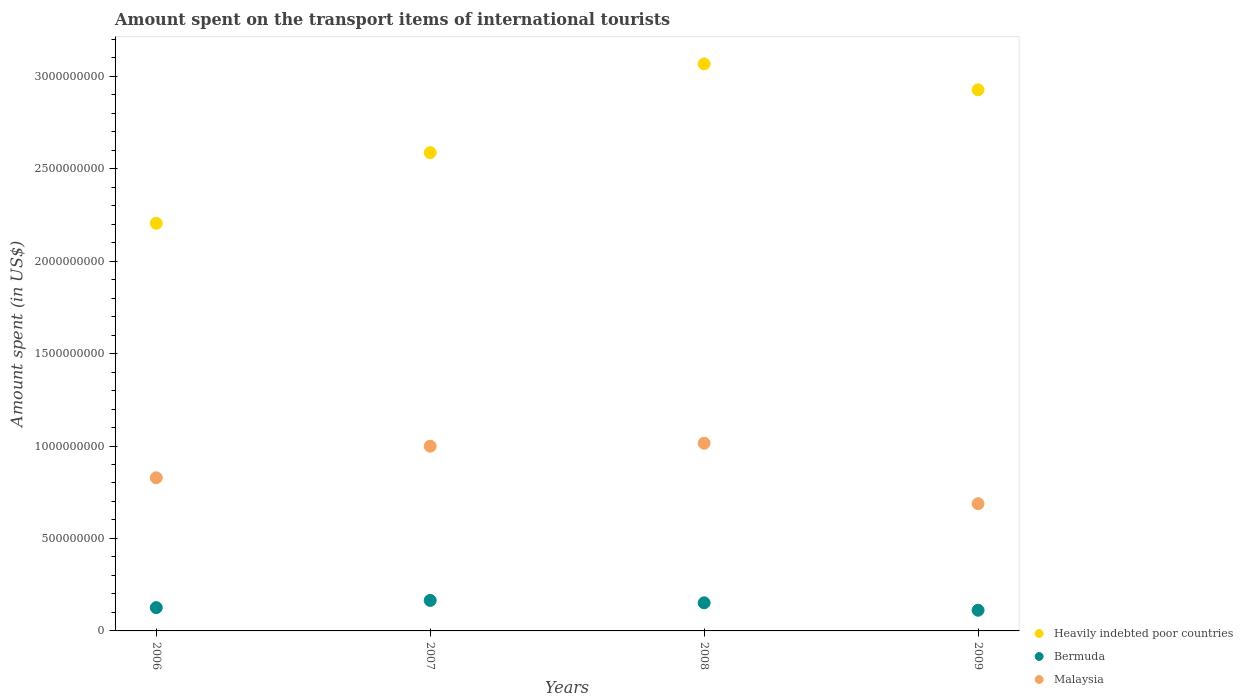What is the amount spent on the transport items of international tourists in Heavily indebted poor countries in 2006?
Offer a very short reply. 2.20e+09. Across all years, what is the maximum amount spent on the transport items of international tourists in Heavily indebted poor countries?
Your response must be concise. 3.07e+09. Across all years, what is the minimum amount spent on the transport items of international tourists in Bermuda?
Offer a terse response. 1.12e+08. In which year was the amount spent on the transport items of international tourists in Heavily indebted poor countries maximum?
Keep it short and to the point. 2008. In which year was the amount spent on the transport items of international tourists in Bermuda minimum?
Offer a terse response. 2009. What is the total amount spent on the transport items of international tourists in Bermuda in the graph?
Offer a very short reply. 5.55e+08. What is the difference between the amount spent on the transport items of international tourists in Bermuda in 2007 and that in 2008?
Your answer should be compact. 1.30e+07. What is the difference between the amount spent on the transport items of international tourists in Malaysia in 2006 and the amount spent on the transport items of international tourists in Heavily indebted poor countries in 2008?
Provide a short and direct response. -2.24e+09. What is the average amount spent on the transport items of international tourists in Malaysia per year?
Offer a terse response. 8.82e+08. In the year 2008, what is the difference between the amount spent on the transport items of international tourists in Heavily indebted poor countries and amount spent on the transport items of international tourists in Bermuda?
Make the answer very short. 2.91e+09. What is the ratio of the amount spent on the transport items of international tourists in Heavily indebted poor countries in 2006 to that in 2008?
Provide a short and direct response. 0.72. What is the difference between the highest and the second highest amount spent on the transport items of international tourists in Malaysia?
Your answer should be compact. 1.60e+07. What is the difference between the highest and the lowest amount spent on the transport items of international tourists in Bermuda?
Provide a short and direct response. 5.30e+07. Is it the case that in every year, the sum of the amount spent on the transport items of international tourists in Malaysia and amount spent on the transport items of international tourists in Heavily indebted poor countries  is greater than the amount spent on the transport items of international tourists in Bermuda?
Offer a very short reply. Yes. Does the amount spent on the transport items of international tourists in Malaysia monotonically increase over the years?
Ensure brevity in your answer.  No. Is the amount spent on the transport items of international tourists in Heavily indebted poor countries strictly greater than the amount spent on the transport items of international tourists in Bermuda over the years?
Make the answer very short. Yes. How many dotlines are there?
Make the answer very short. 3. How many years are there in the graph?
Provide a short and direct response. 4. What is the difference between two consecutive major ticks on the Y-axis?
Give a very brief answer. 5.00e+08. Are the values on the major ticks of Y-axis written in scientific E-notation?
Offer a very short reply. No. Does the graph contain any zero values?
Ensure brevity in your answer.  No. Does the graph contain grids?
Ensure brevity in your answer.  No. Where does the legend appear in the graph?
Keep it short and to the point. Bottom right. How many legend labels are there?
Ensure brevity in your answer.  3. What is the title of the graph?
Your answer should be very brief. Amount spent on the transport items of international tourists. Does "Lithuania" appear as one of the legend labels in the graph?
Provide a short and direct response. No. What is the label or title of the X-axis?
Provide a short and direct response. Years. What is the label or title of the Y-axis?
Your answer should be very brief. Amount spent (in US$). What is the Amount spent (in US$) of Heavily indebted poor countries in 2006?
Your response must be concise. 2.20e+09. What is the Amount spent (in US$) of Bermuda in 2006?
Your answer should be very brief. 1.26e+08. What is the Amount spent (in US$) in Malaysia in 2006?
Your response must be concise. 8.28e+08. What is the Amount spent (in US$) of Heavily indebted poor countries in 2007?
Provide a short and direct response. 2.59e+09. What is the Amount spent (in US$) in Bermuda in 2007?
Provide a succinct answer. 1.65e+08. What is the Amount spent (in US$) in Malaysia in 2007?
Your answer should be very brief. 9.99e+08. What is the Amount spent (in US$) in Heavily indebted poor countries in 2008?
Provide a succinct answer. 3.07e+09. What is the Amount spent (in US$) of Bermuda in 2008?
Offer a very short reply. 1.52e+08. What is the Amount spent (in US$) in Malaysia in 2008?
Offer a terse response. 1.02e+09. What is the Amount spent (in US$) in Heavily indebted poor countries in 2009?
Ensure brevity in your answer.  2.93e+09. What is the Amount spent (in US$) in Bermuda in 2009?
Provide a succinct answer. 1.12e+08. What is the Amount spent (in US$) in Malaysia in 2009?
Keep it short and to the point. 6.88e+08. Across all years, what is the maximum Amount spent (in US$) in Heavily indebted poor countries?
Your answer should be compact. 3.07e+09. Across all years, what is the maximum Amount spent (in US$) in Bermuda?
Give a very brief answer. 1.65e+08. Across all years, what is the maximum Amount spent (in US$) of Malaysia?
Your answer should be very brief. 1.02e+09. Across all years, what is the minimum Amount spent (in US$) in Heavily indebted poor countries?
Your answer should be compact. 2.20e+09. Across all years, what is the minimum Amount spent (in US$) in Bermuda?
Give a very brief answer. 1.12e+08. Across all years, what is the minimum Amount spent (in US$) in Malaysia?
Ensure brevity in your answer.  6.88e+08. What is the total Amount spent (in US$) of Heavily indebted poor countries in the graph?
Offer a terse response. 1.08e+1. What is the total Amount spent (in US$) in Bermuda in the graph?
Give a very brief answer. 5.55e+08. What is the total Amount spent (in US$) of Malaysia in the graph?
Give a very brief answer. 3.53e+09. What is the difference between the Amount spent (in US$) in Heavily indebted poor countries in 2006 and that in 2007?
Ensure brevity in your answer.  -3.82e+08. What is the difference between the Amount spent (in US$) of Bermuda in 2006 and that in 2007?
Ensure brevity in your answer.  -3.90e+07. What is the difference between the Amount spent (in US$) in Malaysia in 2006 and that in 2007?
Your answer should be compact. -1.71e+08. What is the difference between the Amount spent (in US$) in Heavily indebted poor countries in 2006 and that in 2008?
Your answer should be very brief. -8.62e+08. What is the difference between the Amount spent (in US$) of Bermuda in 2006 and that in 2008?
Your answer should be very brief. -2.60e+07. What is the difference between the Amount spent (in US$) in Malaysia in 2006 and that in 2008?
Offer a very short reply. -1.87e+08. What is the difference between the Amount spent (in US$) of Heavily indebted poor countries in 2006 and that in 2009?
Keep it short and to the point. -7.22e+08. What is the difference between the Amount spent (in US$) in Bermuda in 2006 and that in 2009?
Keep it short and to the point. 1.40e+07. What is the difference between the Amount spent (in US$) in Malaysia in 2006 and that in 2009?
Your answer should be compact. 1.40e+08. What is the difference between the Amount spent (in US$) in Heavily indebted poor countries in 2007 and that in 2008?
Your answer should be very brief. -4.80e+08. What is the difference between the Amount spent (in US$) of Bermuda in 2007 and that in 2008?
Give a very brief answer. 1.30e+07. What is the difference between the Amount spent (in US$) in Malaysia in 2007 and that in 2008?
Keep it short and to the point. -1.60e+07. What is the difference between the Amount spent (in US$) of Heavily indebted poor countries in 2007 and that in 2009?
Give a very brief answer. -3.40e+08. What is the difference between the Amount spent (in US$) of Bermuda in 2007 and that in 2009?
Offer a terse response. 5.30e+07. What is the difference between the Amount spent (in US$) of Malaysia in 2007 and that in 2009?
Your answer should be compact. 3.11e+08. What is the difference between the Amount spent (in US$) in Heavily indebted poor countries in 2008 and that in 2009?
Give a very brief answer. 1.40e+08. What is the difference between the Amount spent (in US$) in Bermuda in 2008 and that in 2009?
Offer a terse response. 4.00e+07. What is the difference between the Amount spent (in US$) in Malaysia in 2008 and that in 2009?
Keep it short and to the point. 3.27e+08. What is the difference between the Amount spent (in US$) in Heavily indebted poor countries in 2006 and the Amount spent (in US$) in Bermuda in 2007?
Offer a terse response. 2.04e+09. What is the difference between the Amount spent (in US$) of Heavily indebted poor countries in 2006 and the Amount spent (in US$) of Malaysia in 2007?
Your answer should be compact. 1.21e+09. What is the difference between the Amount spent (in US$) in Bermuda in 2006 and the Amount spent (in US$) in Malaysia in 2007?
Offer a very short reply. -8.73e+08. What is the difference between the Amount spent (in US$) in Heavily indebted poor countries in 2006 and the Amount spent (in US$) in Bermuda in 2008?
Your response must be concise. 2.05e+09. What is the difference between the Amount spent (in US$) of Heavily indebted poor countries in 2006 and the Amount spent (in US$) of Malaysia in 2008?
Provide a short and direct response. 1.19e+09. What is the difference between the Amount spent (in US$) in Bermuda in 2006 and the Amount spent (in US$) in Malaysia in 2008?
Your response must be concise. -8.89e+08. What is the difference between the Amount spent (in US$) in Heavily indebted poor countries in 2006 and the Amount spent (in US$) in Bermuda in 2009?
Provide a short and direct response. 2.09e+09. What is the difference between the Amount spent (in US$) of Heavily indebted poor countries in 2006 and the Amount spent (in US$) of Malaysia in 2009?
Offer a very short reply. 1.52e+09. What is the difference between the Amount spent (in US$) of Bermuda in 2006 and the Amount spent (in US$) of Malaysia in 2009?
Offer a very short reply. -5.62e+08. What is the difference between the Amount spent (in US$) of Heavily indebted poor countries in 2007 and the Amount spent (in US$) of Bermuda in 2008?
Give a very brief answer. 2.43e+09. What is the difference between the Amount spent (in US$) of Heavily indebted poor countries in 2007 and the Amount spent (in US$) of Malaysia in 2008?
Your answer should be very brief. 1.57e+09. What is the difference between the Amount spent (in US$) in Bermuda in 2007 and the Amount spent (in US$) in Malaysia in 2008?
Your answer should be very brief. -8.50e+08. What is the difference between the Amount spent (in US$) in Heavily indebted poor countries in 2007 and the Amount spent (in US$) in Bermuda in 2009?
Provide a succinct answer. 2.47e+09. What is the difference between the Amount spent (in US$) in Heavily indebted poor countries in 2007 and the Amount spent (in US$) in Malaysia in 2009?
Provide a succinct answer. 1.90e+09. What is the difference between the Amount spent (in US$) in Bermuda in 2007 and the Amount spent (in US$) in Malaysia in 2009?
Provide a short and direct response. -5.23e+08. What is the difference between the Amount spent (in US$) of Heavily indebted poor countries in 2008 and the Amount spent (in US$) of Bermuda in 2009?
Offer a terse response. 2.95e+09. What is the difference between the Amount spent (in US$) of Heavily indebted poor countries in 2008 and the Amount spent (in US$) of Malaysia in 2009?
Provide a succinct answer. 2.38e+09. What is the difference between the Amount spent (in US$) in Bermuda in 2008 and the Amount spent (in US$) in Malaysia in 2009?
Provide a short and direct response. -5.36e+08. What is the average Amount spent (in US$) of Heavily indebted poor countries per year?
Make the answer very short. 2.70e+09. What is the average Amount spent (in US$) in Bermuda per year?
Ensure brevity in your answer.  1.39e+08. What is the average Amount spent (in US$) of Malaysia per year?
Provide a succinct answer. 8.82e+08. In the year 2006, what is the difference between the Amount spent (in US$) of Heavily indebted poor countries and Amount spent (in US$) of Bermuda?
Provide a short and direct response. 2.08e+09. In the year 2006, what is the difference between the Amount spent (in US$) of Heavily indebted poor countries and Amount spent (in US$) of Malaysia?
Provide a succinct answer. 1.38e+09. In the year 2006, what is the difference between the Amount spent (in US$) in Bermuda and Amount spent (in US$) in Malaysia?
Keep it short and to the point. -7.02e+08. In the year 2007, what is the difference between the Amount spent (in US$) of Heavily indebted poor countries and Amount spent (in US$) of Bermuda?
Keep it short and to the point. 2.42e+09. In the year 2007, what is the difference between the Amount spent (in US$) of Heavily indebted poor countries and Amount spent (in US$) of Malaysia?
Give a very brief answer. 1.59e+09. In the year 2007, what is the difference between the Amount spent (in US$) of Bermuda and Amount spent (in US$) of Malaysia?
Offer a very short reply. -8.34e+08. In the year 2008, what is the difference between the Amount spent (in US$) in Heavily indebted poor countries and Amount spent (in US$) in Bermuda?
Offer a terse response. 2.91e+09. In the year 2008, what is the difference between the Amount spent (in US$) in Heavily indebted poor countries and Amount spent (in US$) in Malaysia?
Your answer should be very brief. 2.05e+09. In the year 2008, what is the difference between the Amount spent (in US$) in Bermuda and Amount spent (in US$) in Malaysia?
Your answer should be very brief. -8.63e+08. In the year 2009, what is the difference between the Amount spent (in US$) of Heavily indebted poor countries and Amount spent (in US$) of Bermuda?
Your answer should be very brief. 2.81e+09. In the year 2009, what is the difference between the Amount spent (in US$) in Heavily indebted poor countries and Amount spent (in US$) in Malaysia?
Ensure brevity in your answer.  2.24e+09. In the year 2009, what is the difference between the Amount spent (in US$) in Bermuda and Amount spent (in US$) in Malaysia?
Provide a succinct answer. -5.76e+08. What is the ratio of the Amount spent (in US$) of Heavily indebted poor countries in 2006 to that in 2007?
Your response must be concise. 0.85. What is the ratio of the Amount spent (in US$) of Bermuda in 2006 to that in 2007?
Your answer should be very brief. 0.76. What is the ratio of the Amount spent (in US$) of Malaysia in 2006 to that in 2007?
Provide a succinct answer. 0.83. What is the ratio of the Amount spent (in US$) of Heavily indebted poor countries in 2006 to that in 2008?
Make the answer very short. 0.72. What is the ratio of the Amount spent (in US$) of Bermuda in 2006 to that in 2008?
Offer a very short reply. 0.83. What is the ratio of the Amount spent (in US$) of Malaysia in 2006 to that in 2008?
Give a very brief answer. 0.82. What is the ratio of the Amount spent (in US$) in Heavily indebted poor countries in 2006 to that in 2009?
Your answer should be very brief. 0.75. What is the ratio of the Amount spent (in US$) in Malaysia in 2006 to that in 2009?
Offer a very short reply. 1.2. What is the ratio of the Amount spent (in US$) of Heavily indebted poor countries in 2007 to that in 2008?
Provide a succinct answer. 0.84. What is the ratio of the Amount spent (in US$) in Bermuda in 2007 to that in 2008?
Ensure brevity in your answer.  1.09. What is the ratio of the Amount spent (in US$) in Malaysia in 2007 to that in 2008?
Your answer should be compact. 0.98. What is the ratio of the Amount spent (in US$) in Heavily indebted poor countries in 2007 to that in 2009?
Ensure brevity in your answer.  0.88. What is the ratio of the Amount spent (in US$) of Bermuda in 2007 to that in 2009?
Keep it short and to the point. 1.47. What is the ratio of the Amount spent (in US$) in Malaysia in 2007 to that in 2009?
Give a very brief answer. 1.45. What is the ratio of the Amount spent (in US$) in Heavily indebted poor countries in 2008 to that in 2009?
Provide a succinct answer. 1.05. What is the ratio of the Amount spent (in US$) in Bermuda in 2008 to that in 2009?
Make the answer very short. 1.36. What is the ratio of the Amount spent (in US$) in Malaysia in 2008 to that in 2009?
Ensure brevity in your answer.  1.48. What is the difference between the highest and the second highest Amount spent (in US$) in Heavily indebted poor countries?
Your answer should be very brief. 1.40e+08. What is the difference between the highest and the second highest Amount spent (in US$) of Bermuda?
Your answer should be very brief. 1.30e+07. What is the difference between the highest and the second highest Amount spent (in US$) of Malaysia?
Provide a short and direct response. 1.60e+07. What is the difference between the highest and the lowest Amount spent (in US$) in Heavily indebted poor countries?
Offer a very short reply. 8.62e+08. What is the difference between the highest and the lowest Amount spent (in US$) of Bermuda?
Your response must be concise. 5.30e+07. What is the difference between the highest and the lowest Amount spent (in US$) in Malaysia?
Your answer should be very brief. 3.27e+08. 